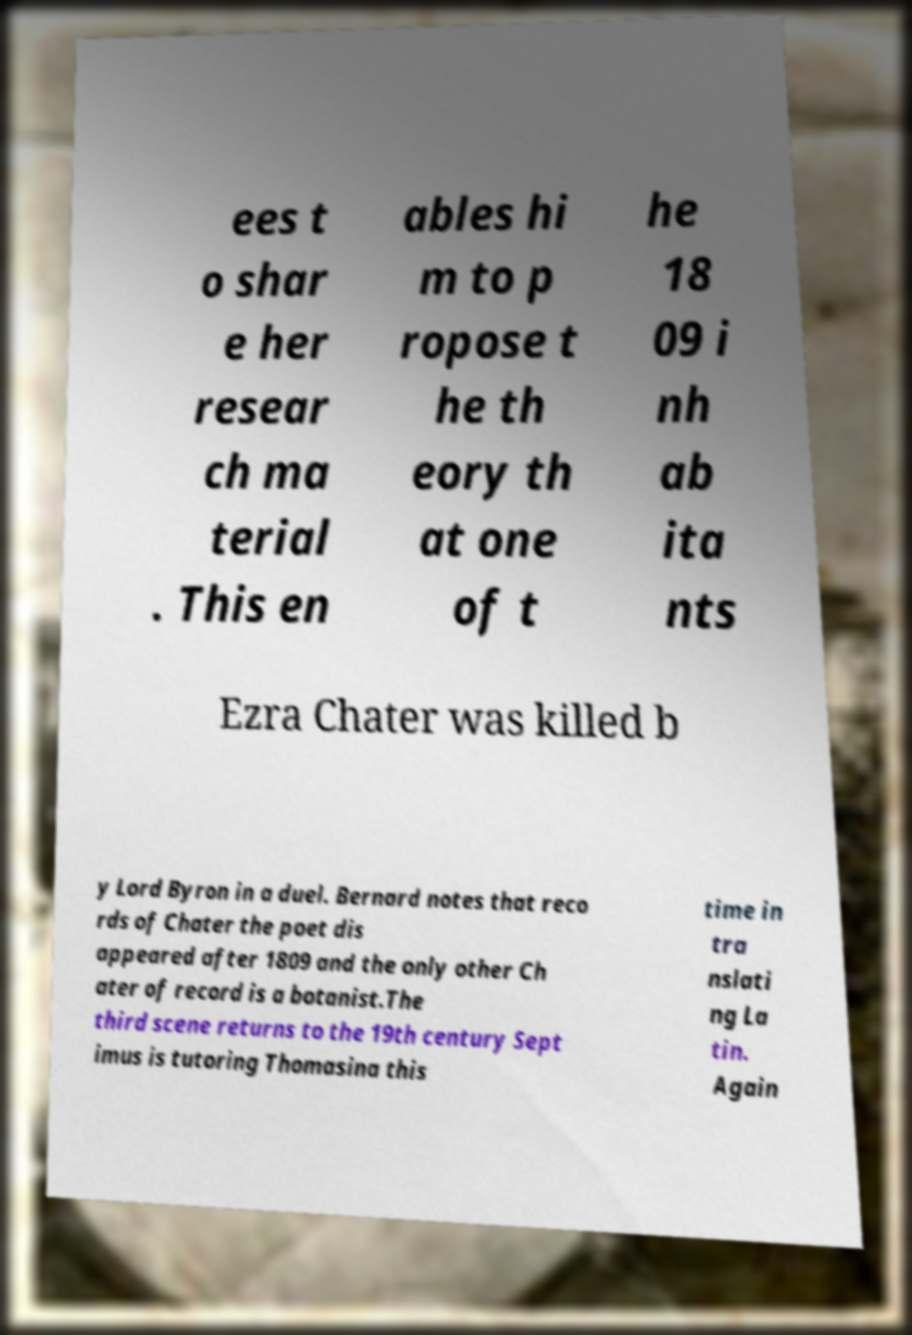Please identify and transcribe the text found in this image. ees t o shar e her resear ch ma terial . This en ables hi m to p ropose t he th eory th at one of t he 18 09 i nh ab ita nts Ezra Chater was killed b y Lord Byron in a duel. Bernard notes that reco rds of Chater the poet dis appeared after 1809 and the only other Ch ater of record is a botanist.The third scene returns to the 19th century Sept imus is tutoring Thomasina this time in tra nslati ng La tin. Again 